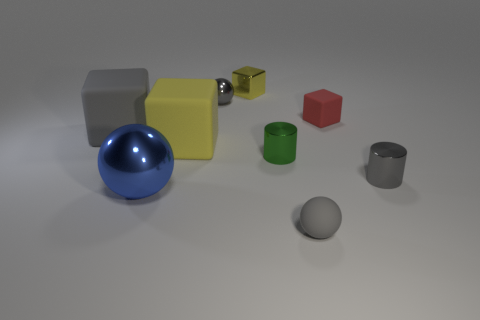What is the color of the matte ball?
Keep it short and to the point. Gray. Are any gray cylinders visible?
Make the answer very short. Yes. Are there any green metal cylinders behind the red rubber thing?
Ensure brevity in your answer.  No. What material is the big blue object that is the same shape as the tiny gray rubber thing?
Your response must be concise. Metal. Is there any other thing that has the same material as the big yellow thing?
Ensure brevity in your answer.  Yes. How many other things are there of the same shape as the big blue object?
Offer a terse response. 2. There is a small ball in front of the small gray shiny thing that is in front of the small gray metal sphere; how many tiny gray objects are in front of it?
Offer a very short reply. 0. What number of big gray objects have the same shape as the yellow metal thing?
Make the answer very short. 1. There is a tiny shiny cube that is behind the green metal cylinder; is its color the same as the small matte ball?
Your answer should be very brief. No. There is a gray matte thing that is behind the cylinder in front of the tiny cylinder to the left of the small rubber block; what shape is it?
Make the answer very short. Cube. 